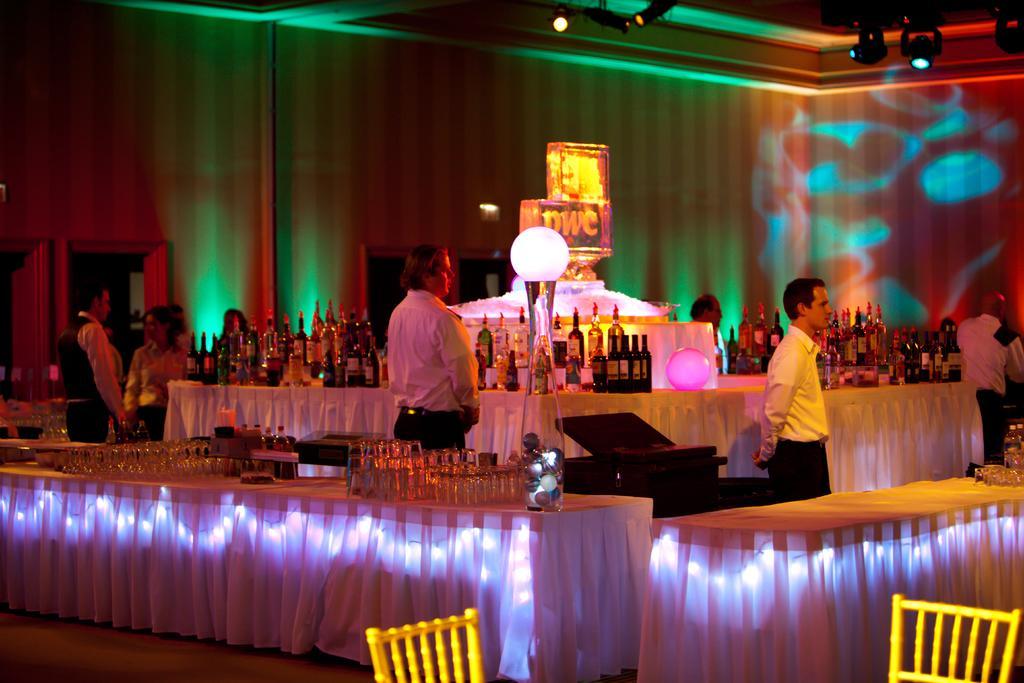Can you describe this image briefly? In this image I can see the group of people standing and wearing the dresses. In-front of these people I can see the table. On the table there are many wines bottles and glasses. I can some yellow color objects in the front. In the background there is a wall and the lights in the top. 